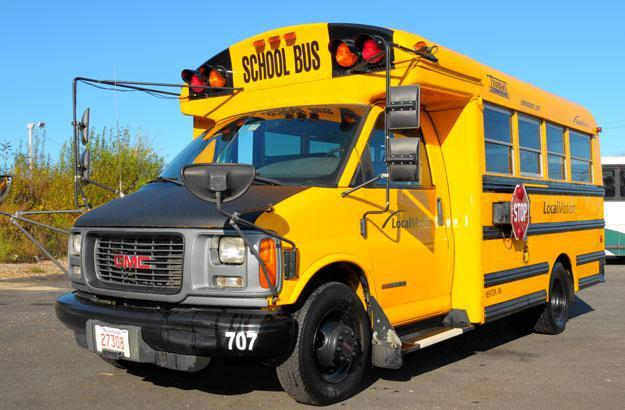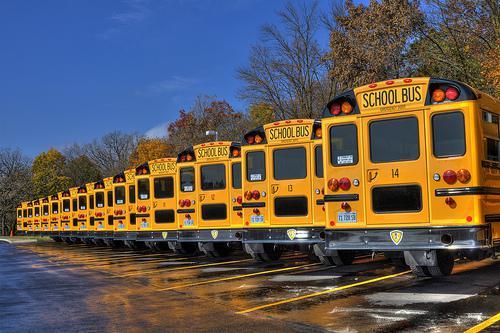The first image is the image on the left, the second image is the image on the right. Assess this claim about the two images: "One image shows the back of three or more school buses parked at an angle, while a second image shows the front of one bus.". Correct or not? Answer yes or no. Yes. The first image is the image on the left, the second image is the image on the right. Evaluate the accuracy of this statement regarding the images: "There are more buses in the image on the right.". Is it true? Answer yes or no. Yes. 